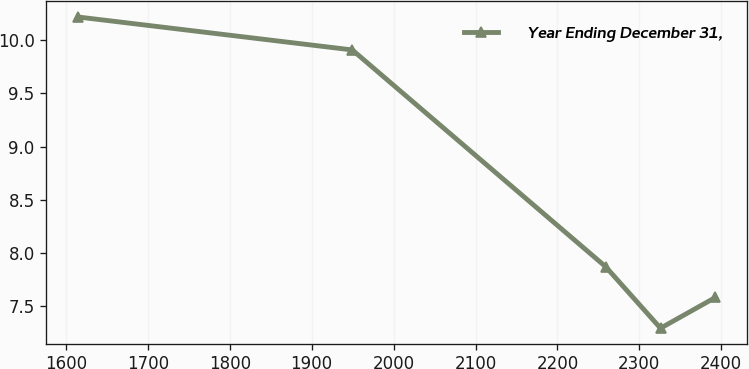<chart> <loc_0><loc_0><loc_500><loc_500><line_chart><ecel><fcel>Year Ending December 31,<nl><fcel>1614.99<fcel>10.22<nl><fcel>1949.57<fcel>9.91<nl><fcel>2258.72<fcel>7.87<nl><fcel>2325.81<fcel>7.29<nl><fcel>2392.9<fcel>7.58<nl></chart> 